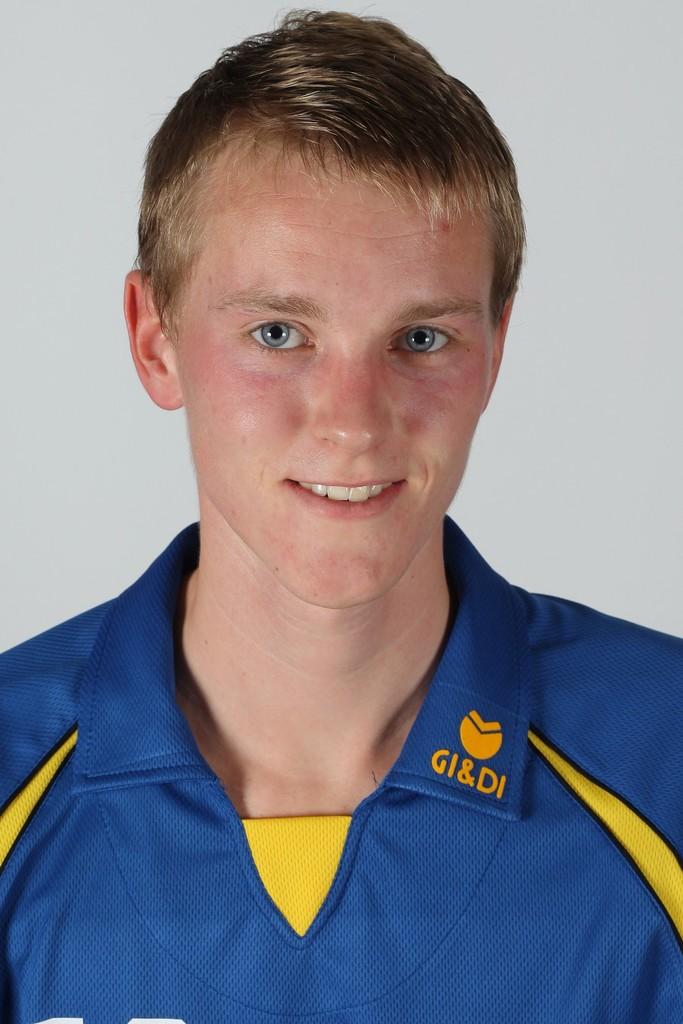What does his shirt collar say?
Provide a succinct answer. Gi&di. What color is the letters on the collar?
Make the answer very short. Yellow. 